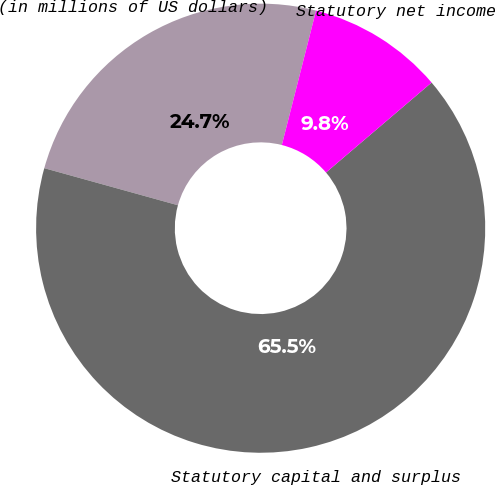Convert chart. <chart><loc_0><loc_0><loc_500><loc_500><pie_chart><fcel>(in millions of US dollars)<fcel>Statutory capital and surplus<fcel>Statutory net income<nl><fcel>24.66%<fcel>65.54%<fcel>9.8%<nl></chart> 